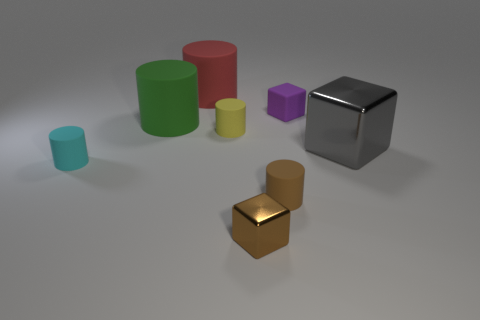What number of purple objects have the same size as the cyan cylinder?
Your answer should be compact. 1. There is a big rubber cylinder that is on the left side of the object that is behind the purple block; how many small brown blocks are to the right of it?
Provide a succinct answer. 1. What number of matte things are on the right side of the cyan thing and on the left side of the red cylinder?
Offer a very short reply. 1. Are there any other things of the same color as the big shiny cube?
Keep it short and to the point. No. How many metallic objects are cyan cylinders or gray cubes?
Your response must be concise. 1. What material is the big thing on the right side of the big cylinder behind the small rubber object behind the tiny yellow thing?
Ensure brevity in your answer.  Metal. What is the material of the big cylinder that is to the left of the big object behind the tiny rubber block?
Provide a succinct answer. Rubber. Do the rubber thing behind the purple matte thing and the rubber object that is left of the green cylinder have the same size?
Your answer should be very brief. No. Is there any other thing that has the same material as the tiny cyan object?
Provide a succinct answer. Yes. What number of large things are cyan blocks or gray things?
Your answer should be very brief. 1. 